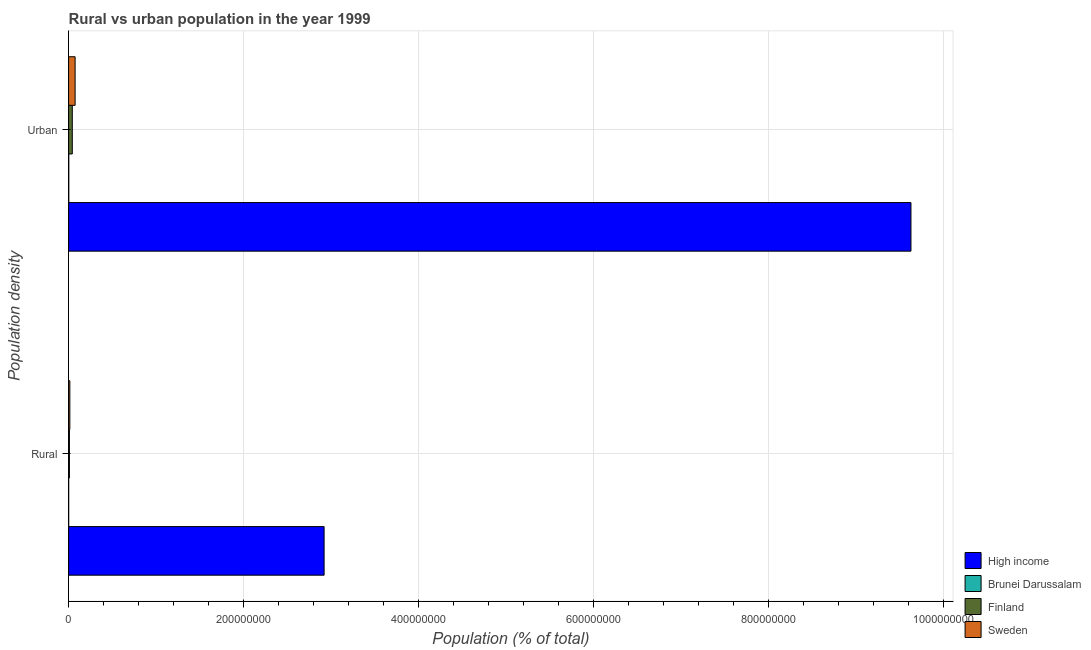How many bars are there on the 2nd tick from the bottom?
Offer a very short reply. 4. What is the label of the 2nd group of bars from the top?
Give a very brief answer. Rural. What is the rural population density in High income?
Make the answer very short. 2.92e+08. Across all countries, what is the maximum rural population density?
Offer a terse response. 2.92e+08. Across all countries, what is the minimum urban population density?
Your response must be concise. 2.29e+05. In which country was the urban population density minimum?
Keep it short and to the point. Brunei Darussalam. What is the total urban population density in the graph?
Make the answer very short. 9.74e+08. What is the difference between the urban population density in High income and that in Finland?
Keep it short and to the point. 9.58e+08. What is the difference between the urban population density in Brunei Darussalam and the rural population density in Sweden?
Make the answer very short. -1.19e+06. What is the average rural population density per country?
Keep it short and to the point. 7.36e+07. What is the difference between the rural population density and urban population density in Sweden?
Give a very brief answer. -6.02e+06. In how many countries, is the urban population density greater than 720000000 %?
Offer a very short reply. 1. What is the ratio of the urban population density in High income to that in Sweden?
Provide a succinct answer. 129.37. In how many countries, is the rural population density greater than the average rural population density taken over all countries?
Your response must be concise. 1. What does the 1st bar from the top in Urban represents?
Offer a very short reply. Sweden. What does the 2nd bar from the bottom in Urban represents?
Ensure brevity in your answer.  Brunei Darussalam. What is the difference between two consecutive major ticks on the X-axis?
Provide a short and direct response. 2.00e+08. Are the values on the major ticks of X-axis written in scientific E-notation?
Your answer should be compact. No. What is the title of the graph?
Your answer should be compact. Rural vs urban population in the year 1999. What is the label or title of the X-axis?
Keep it short and to the point. Population (% of total). What is the label or title of the Y-axis?
Provide a short and direct response. Population density. What is the Population (% of total) of High income in Rural?
Provide a succinct answer. 2.92e+08. What is the Population (% of total) of Brunei Darussalam in Rural?
Offer a very short reply. 9.50e+04. What is the Population (% of total) in Finland in Rural?
Ensure brevity in your answer.  9.33e+05. What is the Population (% of total) in Sweden in Rural?
Make the answer very short. 1.42e+06. What is the Population (% of total) in High income in Urban?
Keep it short and to the point. 9.63e+08. What is the Population (% of total) in Brunei Darussalam in Urban?
Give a very brief answer. 2.29e+05. What is the Population (% of total) in Finland in Urban?
Give a very brief answer. 4.23e+06. What is the Population (% of total) of Sweden in Urban?
Provide a succinct answer. 7.44e+06. Across all Population density, what is the maximum Population (% of total) in High income?
Offer a terse response. 9.63e+08. Across all Population density, what is the maximum Population (% of total) of Brunei Darussalam?
Ensure brevity in your answer.  2.29e+05. Across all Population density, what is the maximum Population (% of total) of Finland?
Offer a very short reply. 4.23e+06. Across all Population density, what is the maximum Population (% of total) in Sweden?
Your answer should be compact. 7.44e+06. Across all Population density, what is the minimum Population (% of total) in High income?
Your answer should be very brief. 2.92e+08. Across all Population density, what is the minimum Population (% of total) of Brunei Darussalam?
Ensure brevity in your answer.  9.50e+04. Across all Population density, what is the minimum Population (% of total) in Finland?
Provide a succinct answer. 9.33e+05. Across all Population density, what is the minimum Population (% of total) of Sweden?
Provide a succinct answer. 1.42e+06. What is the total Population (% of total) in High income in the graph?
Make the answer very short. 1.25e+09. What is the total Population (% of total) of Brunei Darussalam in the graph?
Keep it short and to the point. 3.24e+05. What is the total Population (% of total) of Finland in the graph?
Your answer should be very brief. 5.17e+06. What is the total Population (% of total) of Sweden in the graph?
Give a very brief answer. 8.86e+06. What is the difference between the Population (% of total) in High income in Rural and that in Urban?
Provide a succinct answer. -6.71e+08. What is the difference between the Population (% of total) in Brunei Darussalam in Rural and that in Urban?
Offer a very short reply. -1.34e+05. What is the difference between the Population (% of total) in Finland in Rural and that in Urban?
Your answer should be compact. -3.30e+06. What is the difference between the Population (% of total) in Sweden in Rural and that in Urban?
Your answer should be compact. -6.02e+06. What is the difference between the Population (% of total) of High income in Rural and the Population (% of total) of Brunei Darussalam in Urban?
Provide a succinct answer. 2.92e+08. What is the difference between the Population (% of total) in High income in Rural and the Population (% of total) in Finland in Urban?
Keep it short and to the point. 2.88e+08. What is the difference between the Population (% of total) of High income in Rural and the Population (% of total) of Sweden in Urban?
Your response must be concise. 2.85e+08. What is the difference between the Population (% of total) in Brunei Darussalam in Rural and the Population (% of total) in Finland in Urban?
Provide a short and direct response. -4.14e+06. What is the difference between the Population (% of total) in Brunei Darussalam in Rural and the Population (% of total) in Sweden in Urban?
Give a very brief answer. -7.35e+06. What is the difference between the Population (% of total) of Finland in Rural and the Population (% of total) of Sweden in Urban?
Offer a very short reply. -6.51e+06. What is the average Population (% of total) in High income per Population density?
Offer a very short reply. 6.27e+08. What is the average Population (% of total) in Brunei Darussalam per Population density?
Your answer should be very brief. 1.62e+05. What is the average Population (% of total) in Finland per Population density?
Offer a terse response. 2.58e+06. What is the average Population (% of total) of Sweden per Population density?
Your response must be concise. 4.43e+06. What is the difference between the Population (% of total) of High income and Population (% of total) of Brunei Darussalam in Rural?
Provide a short and direct response. 2.92e+08. What is the difference between the Population (% of total) in High income and Population (% of total) in Finland in Rural?
Your answer should be very brief. 2.91e+08. What is the difference between the Population (% of total) of High income and Population (% of total) of Sweden in Rural?
Your answer should be very brief. 2.91e+08. What is the difference between the Population (% of total) of Brunei Darussalam and Population (% of total) of Finland in Rural?
Provide a short and direct response. -8.38e+05. What is the difference between the Population (% of total) in Brunei Darussalam and Population (% of total) in Sweden in Rural?
Give a very brief answer. -1.32e+06. What is the difference between the Population (% of total) in Finland and Population (% of total) in Sweden in Rural?
Your answer should be very brief. -4.85e+05. What is the difference between the Population (% of total) of High income and Population (% of total) of Brunei Darussalam in Urban?
Offer a terse response. 9.62e+08. What is the difference between the Population (% of total) of High income and Population (% of total) of Finland in Urban?
Keep it short and to the point. 9.58e+08. What is the difference between the Population (% of total) of High income and Population (% of total) of Sweden in Urban?
Your answer should be very brief. 9.55e+08. What is the difference between the Population (% of total) in Brunei Darussalam and Population (% of total) in Finland in Urban?
Your answer should be compact. -4.00e+06. What is the difference between the Population (% of total) of Brunei Darussalam and Population (% of total) of Sweden in Urban?
Provide a succinct answer. -7.21e+06. What is the difference between the Population (% of total) of Finland and Population (% of total) of Sweden in Urban?
Provide a succinct answer. -3.21e+06. What is the ratio of the Population (% of total) in High income in Rural to that in Urban?
Offer a terse response. 0.3. What is the ratio of the Population (% of total) of Brunei Darussalam in Rural to that in Urban?
Make the answer very short. 0.41. What is the ratio of the Population (% of total) in Finland in Rural to that in Urban?
Give a very brief answer. 0.22. What is the ratio of the Population (% of total) in Sweden in Rural to that in Urban?
Provide a succinct answer. 0.19. What is the difference between the highest and the second highest Population (% of total) in High income?
Your response must be concise. 6.71e+08. What is the difference between the highest and the second highest Population (% of total) in Brunei Darussalam?
Offer a very short reply. 1.34e+05. What is the difference between the highest and the second highest Population (% of total) of Finland?
Your answer should be very brief. 3.30e+06. What is the difference between the highest and the second highest Population (% of total) of Sweden?
Your response must be concise. 6.02e+06. What is the difference between the highest and the lowest Population (% of total) in High income?
Offer a terse response. 6.71e+08. What is the difference between the highest and the lowest Population (% of total) of Brunei Darussalam?
Your answer should be compact. 1.34e+05. What is the difference between the highest and the lowest Population (% of total) of Finland?
Ensure brevity in your answer.  3.30e+06. What is the difference between the highest and the lowest Population (% of total) in Sweden?
Keep it short and to the point. 6.02e+06. 